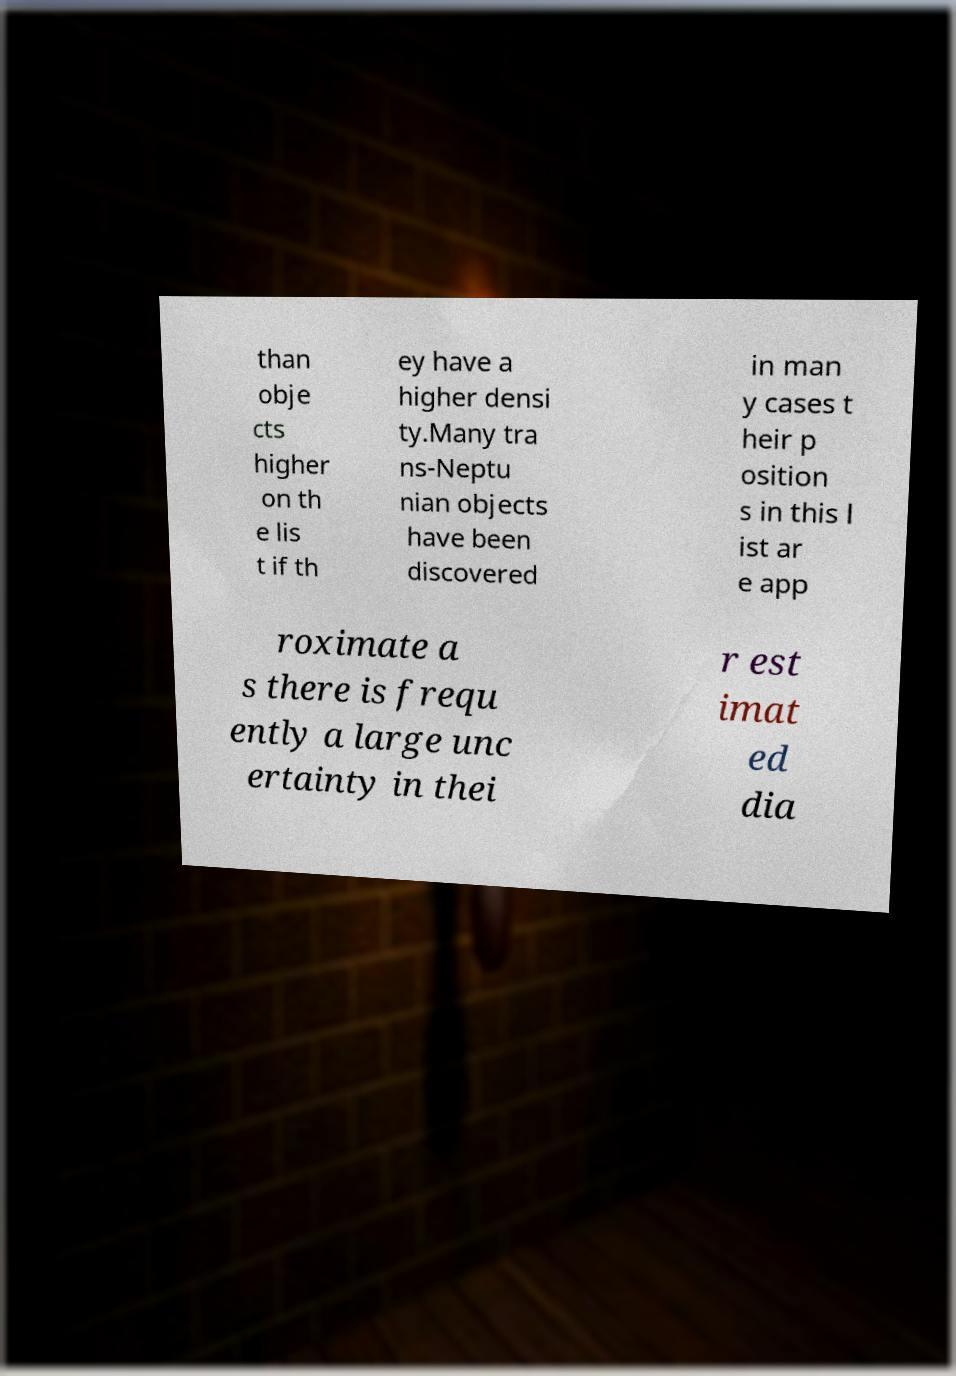Could you extract and type out the text from this image? than obje cts higher on th e lis t if th ey have a higher densi ty.Many tra ns-Neptu nian objects have been discovered in man y cases t heir p osition s in this l ist ar e app roximate a s there is frequ ently a large unc ertainty in thei r est imat ed dia 